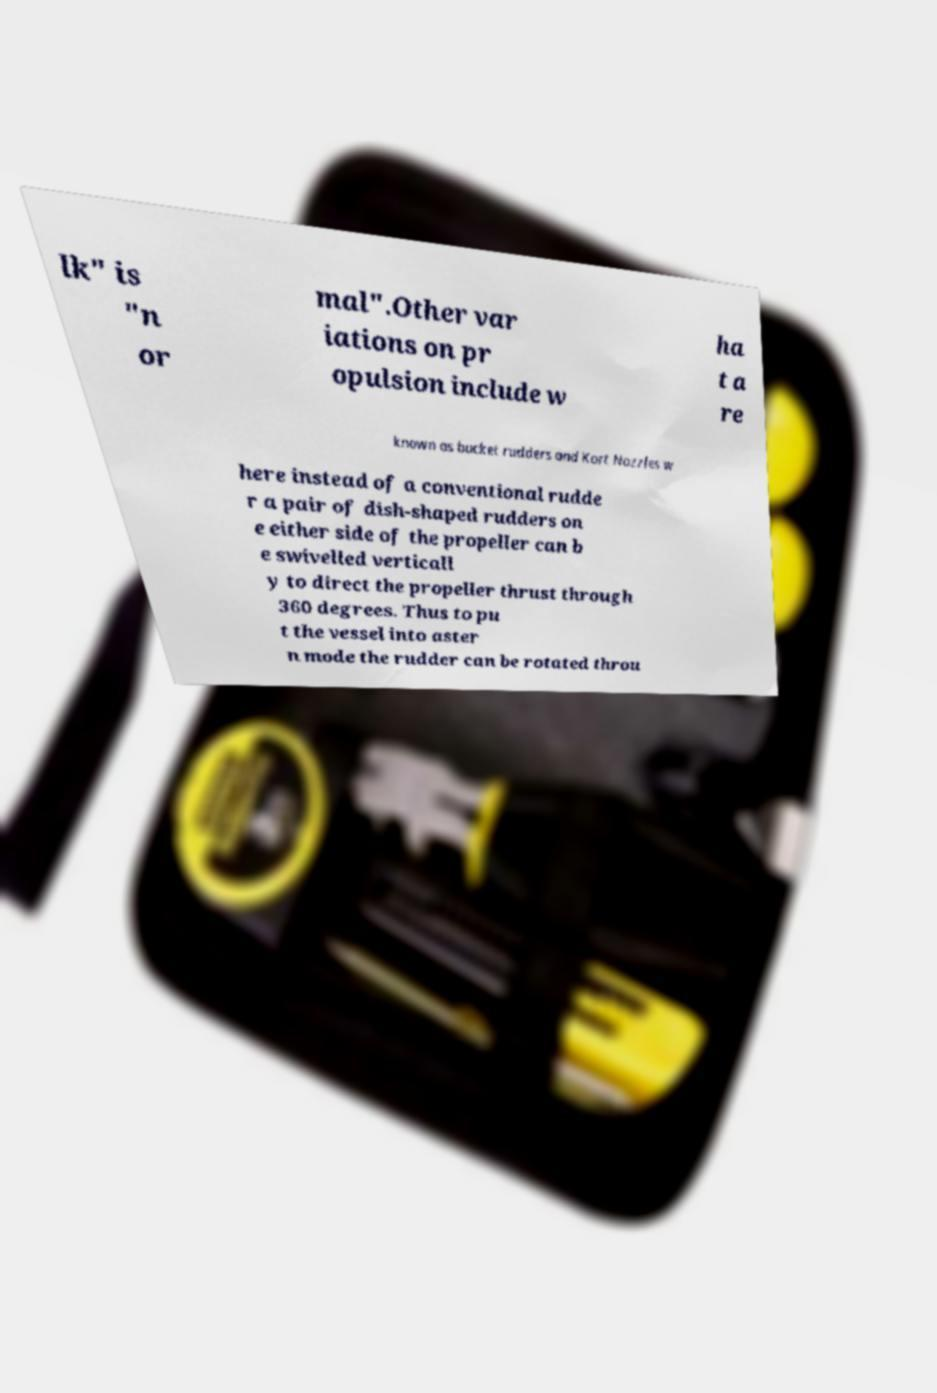Can you accurately transcribe the text from the provided image for me? lk" is "n or mal".Other var iations on pr opulsion include w ha t a re known as bucket rudders and Kort Nozzles w here instead of a conventional rudde r a pair of dish-shaped rudders on e either side of the propeller can b e swivelled verticall y to direct the propeller thrust through 360 degrees. Thus to pu t the vessel into aster n mode the rudder can be rotated throu 